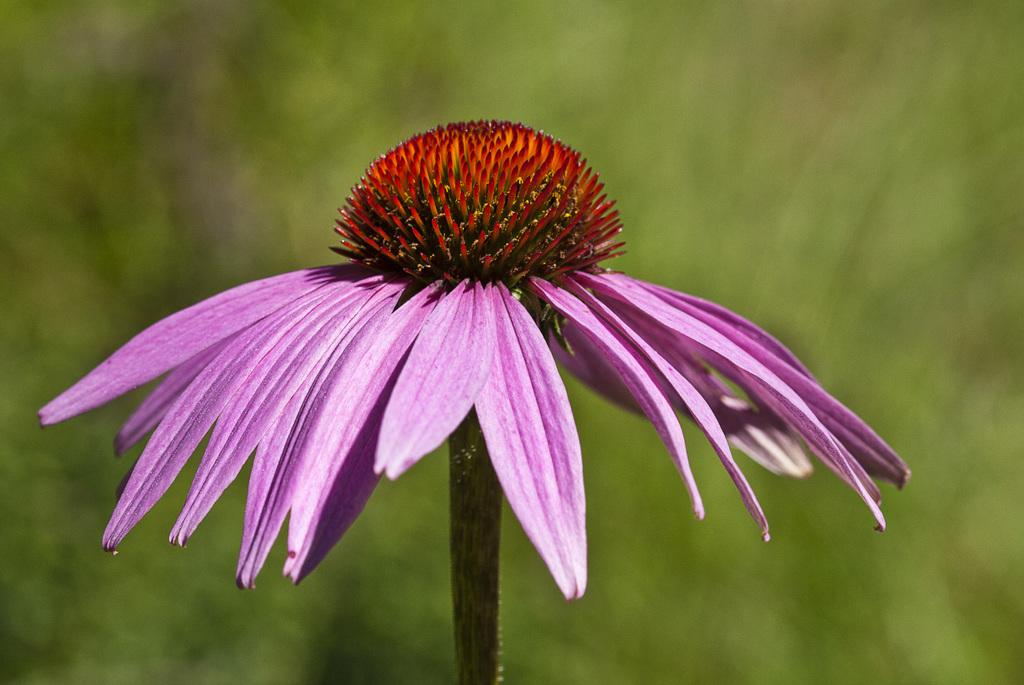What is the main subject of the image? There is a flower in the image. Can you describe the colors of the flower? The flower has pink, red, orange, green, and yellow colors. How would you describe the background of the image? The background of the image is blurry. What color is the background? The background color is green. Can you hear the flower making a statement in the image? The image is a still image and does not contain any sounds or actions, so it is not possible to hear the flower making a statement in the image. 